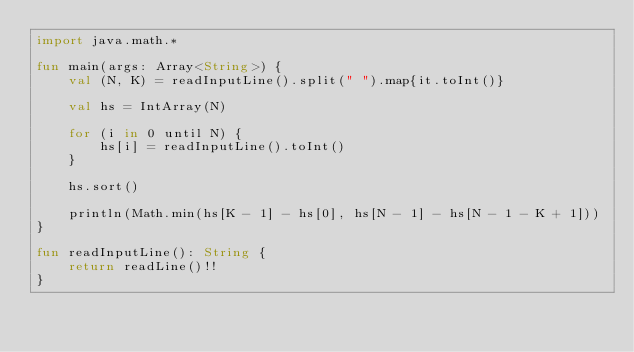<code> <loc_0><loc_0><loc_500><loc_500><_Kotlin_>import java.math.*

fun main(args: Array<String>) {
    val (N, K) = readInputLine().split(" ").map{it.toInt()}
    
    val hs = IntArray(N)
    
    for (i in 0 until N) {
        hs[i] = readInputLine().toInt()
    }
    
    hs.sort()
    
    println(Math.min(hs[K - 1] - hs[0], hs[N - 1] - hs[N - 1 - K + 1]))
}

fun readInputLine(): String {
    return readLine()!!
}
</code> 